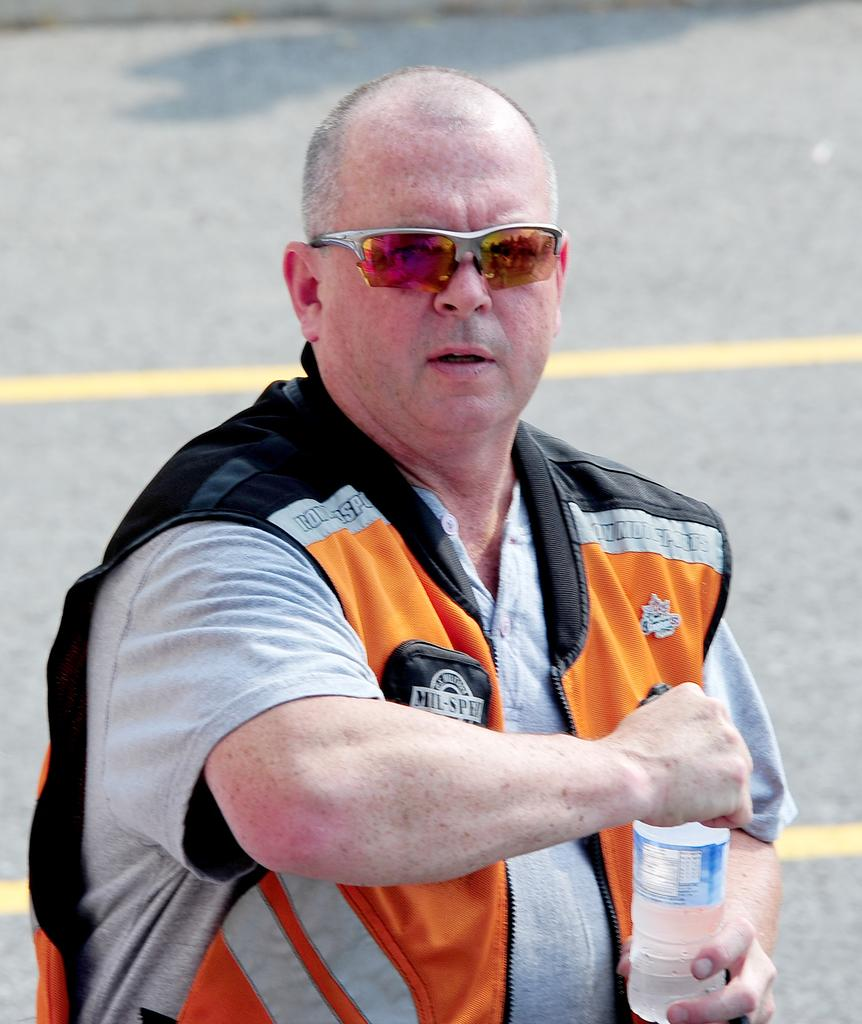Who is present in the image? There is a man in the image. What is the man doing in the image? The man is standing and opening a bottle. What type of stocking is the man wearing in the image? There is no mention of stockings or any clothing items in the image, so it cannot be determined if the man is wearing any stockings. 